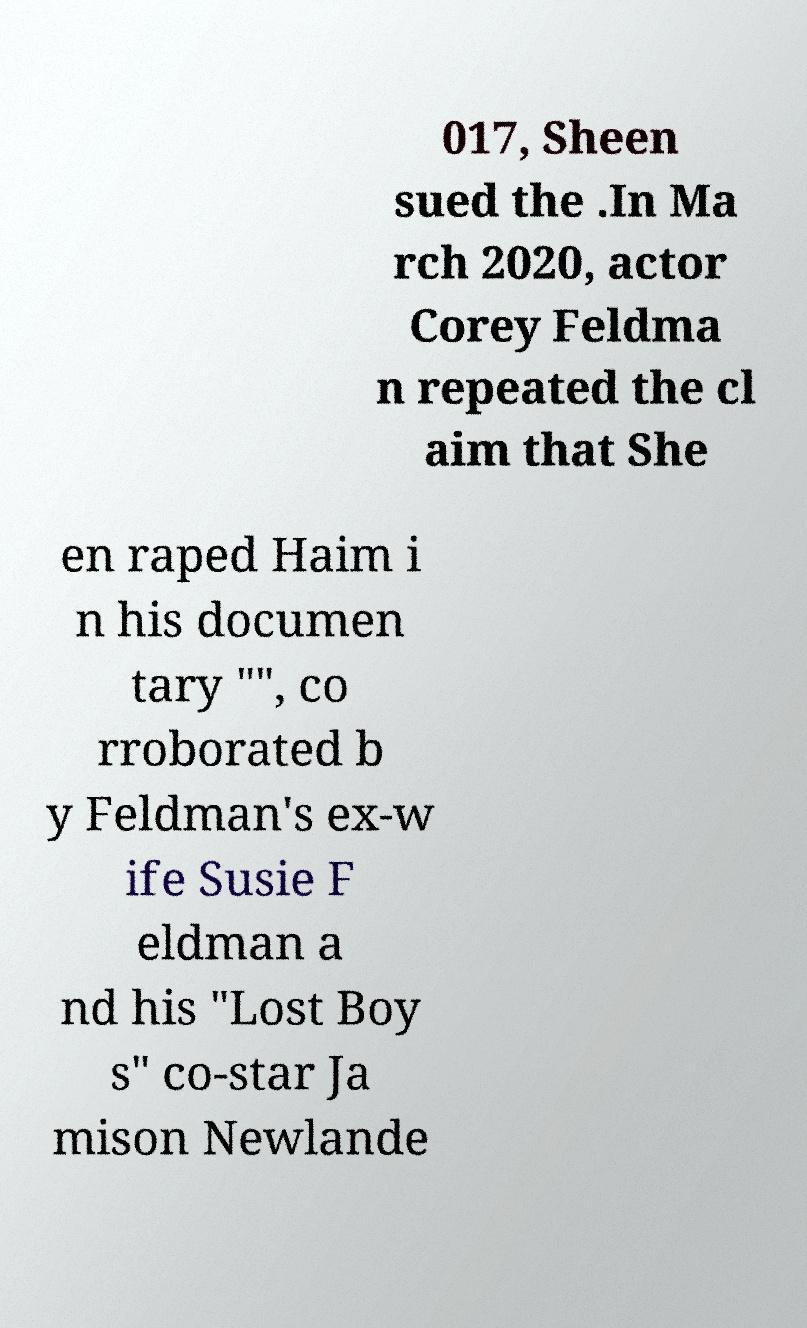Can you accurately transcribe the text from the provided image for me? 017, Sheen sued the .In Ma rch 2020, actor Corey Feldma n repeated the cl aim that She en raped Haim i n his documen tary "", co rroborated b y Feldman's ex-w ife Susie F eldman a nd his "Lost Boy s" co-star Ja mison Newlande 